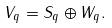Convert formula to latex. <formula><loc_0><loc_0><loc_500><loc_500>V _ { q } = S _ { q } \oplus W _ { q } .</formula> 